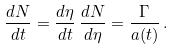Convert formula to latex. <formula><loc_0><loc_0><loc_500><loc_500>\frac { d N } { d t } = \frac { d \eta } { d t } \, \frac { d N } { d \eta } = \frac { \Gamma } { a ( t ) } \, .</formula> 